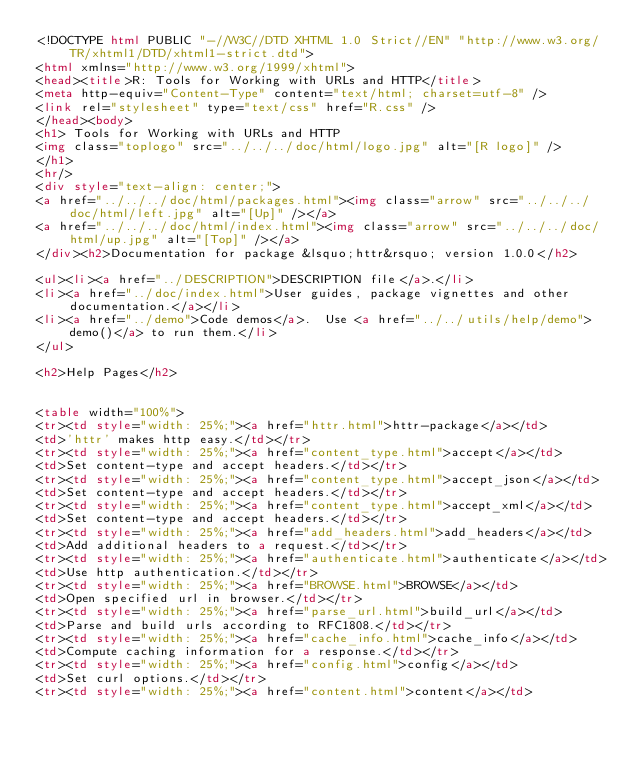<code> <loc_0><loc_0><loc_500><loc_500><_HTML_><!DOCTYPE html PUBLIC "-//W3C//DTD XHTML 1.0 Strict//EN" "http://www.w3.org/TR/xhtml1/DTD/xhtml1-strict.dtd">
<html xmlns="http://www.w3.org/1999/xhtml">
<head><title>R: Tools for Working with URLs and HTTP</title>
<meta http-equiv="Content-Type" content="text/html; charset=utf-8" />
<link rel="stylesheet" type="text/css" href="R.css" />
</head><body>
<h1> Tools for Working with URLs and HTTP
<img class="toplogo" src="../../../doc/html/logo.jpg" alt="[R logo]" />
</h1>
<hr/>
<div style="text-align: center;">
<a href="../../../doc/html/packages.html"><img class="arrow" src="../../../doc/html/left.jpg" alt="[Up]" /></a>
<a href="../../../doc/html/index.html"><img class="arrow" src="../../../doc/html/up.jpg" alt="[Top]" /></a>
</div><h2>Documentation for package &lsquo;httr&rsquo; version 1.0.0</h2>

<ul><li><a href="../DESCRIPTION">DESCRIPTION file</a>.</li>
<li><a href="../doc/index.html">User guides, package vignettes and other documentation.</a></li>
<li><a href="../demo">Code demos</a>.  Use <a href="../../utils/help/demo">demo()</a> to run them.</li>
</ul>

<h2>Help Pages</h2>


<table width="100%">
<tr><td style="width: 25%;"><a href="httr.html">httr-package</a></td>
<td>'httr' makes http easy.</td></tr>
<tr><td style="width: 25%;"><a href="content_type.html">accept</a></td>
<td>Set content-type and accept headers.</td></tr>
<tr><td style="width: 25%;"><a href="content_type.html">accept_json</a></td>
<td>Set content-type and accept headers.</td></tr>
<tr><td style="width: 25%;"><a href="content_type.html">accept_xml</a></td>
<td>Set content-type and accept headers.</td></tr>
<tr><td style="width: 25%;"><a href="add_headers.html">add_headers</a></td>
<td>Add additional headers to a request.</td></tr>
<tr><td style="width: 25%;"><a href="authenticate.html">authenticate</a></td>
<td>Use http authentication.</td></tr>
<tr><td style="width: 25%;"><a href="BROWSE.html">BROWSE</a></td>
<td>Open specified url in browser.</td></tr>
<tr><td style="width: 25%;"><a href="parse_url.html">build_url</a></td>
<td>Parse and build urls according to RFC1808.</td></tr>
<tr><td style="width: 25%;"><a href="cache_info.html">cache_info</a></td>
<td>Compute caching information for a response.</td></tr>
<tr><td style="width: 25%;"><a href="config.html">config</a></td>
<td>Set curl options.</td></tr>
<tr><td style="width: 25%;"><a href="content.html">content</a></td></code> 